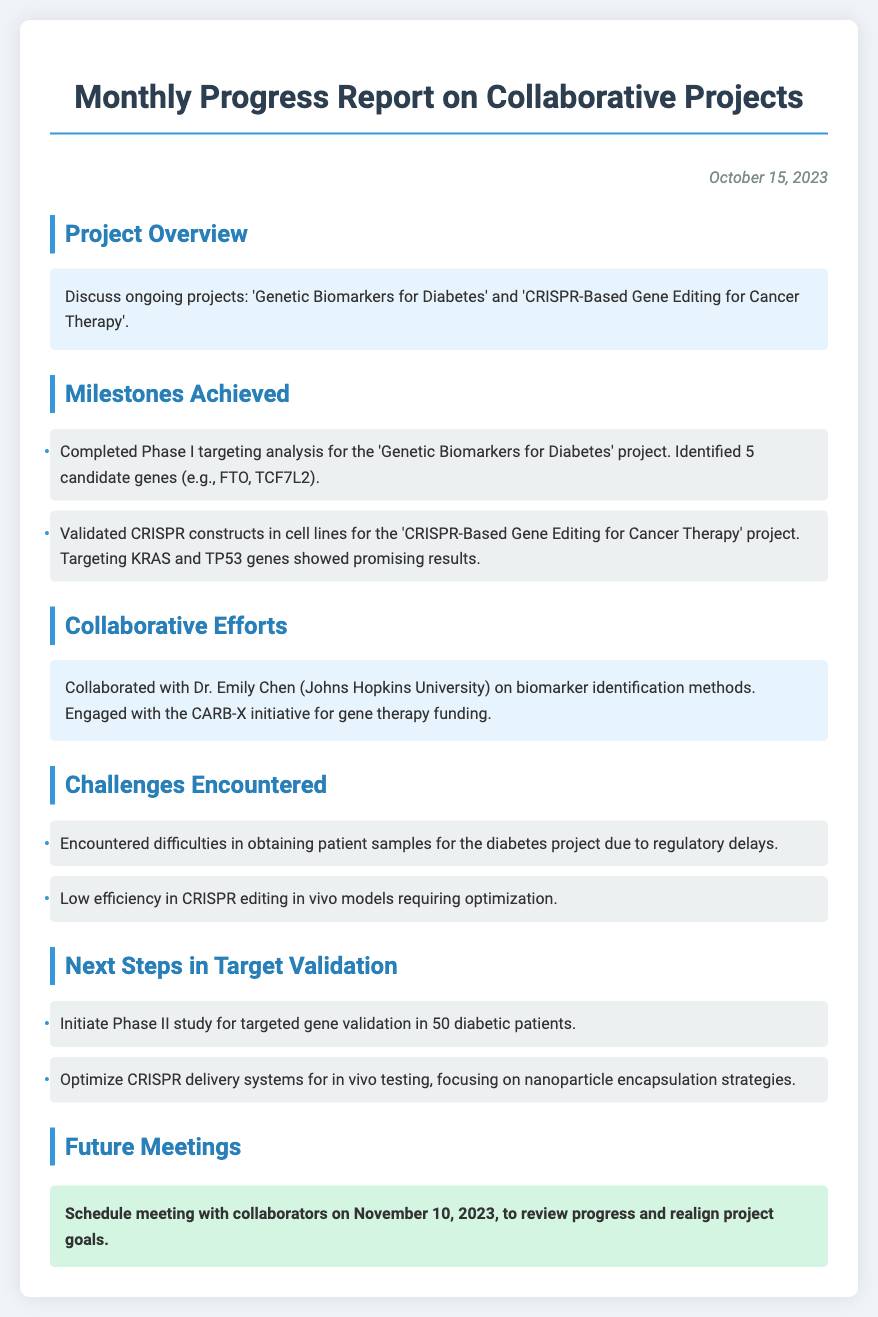What are the two ongoing projects? The document lists two ongoing projects: 'Genetic Biomarkers for Diabetes' and 'CRISPR-Based Gene Editing for Cancer Therapy'.
Answer: 'Genetic Biomarkers for Diabetes', 'CRISPR-Based Gene Editing for Cancer Therapy' How many candidate genes were identified in the diabetes project? The report states that 5 candidate genes were identified in the targeting analysis for the diabetes project.
Answer: 5 Who collaborated on biomarker identification methods? The document mentions collaboration with Dr. Emily Chen from Johns Hopkins University on biomarker identification methods.
Answer: Dr. Emily Chen What is a challenge encountered in the diabetes project? The report describes difficulties in obtaining patient samples for the diabetes project due to regulatory delays as a challenge encountered.
Answer: Regulatory delays When is the next scheduled meeting with collaborators? The document states the meeting with collaborators is scheduled for November 10, 2023.
Answer: November 10, 2023 What is the focus for optimizing CRISPR delivery systems? The next steps indicate a focus on nanoparticle encapsulation strategies for optimizing CRISPR delivery systems.
Answer: Nanoparticle encapsulation strategies What was validated in cell lines for the cancer therapy project? The document notes that CRISPR constructs targeting KRAS and TP53 genes were validated in cell lines for the cancer therapy project.
Answer: CRISPR constructs targeting KRAS and TP53 genes What will be initiated for targeted gene validation? The next steps include initiating a Phase II study for targeted gene validation in diabetic patients.
Answer: Phase II study What type of report is this document? The document summarizes the monthly progress on collaborative projects, which fits the type of a progress report.
Answer: Monthly progress report 